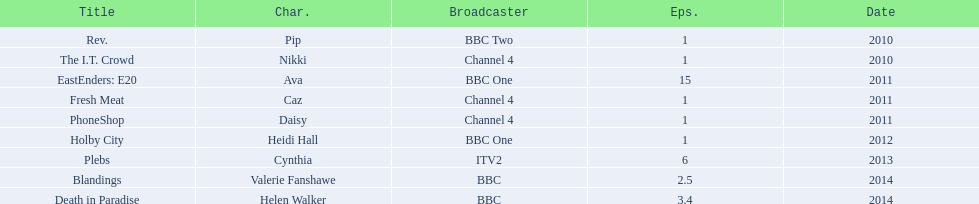Blandings and death in paradise both aired on which broadcaster? BBC. 